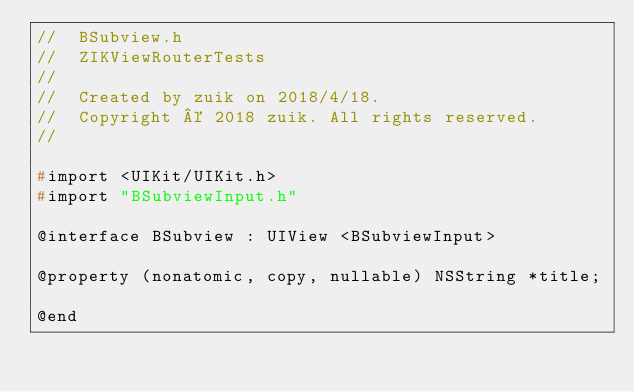Convert code to text. <code><loc_0><loc_0><loc_500><loc_500><_C_>//  BSubview.h
//  ZIKViewRouterTests
//
//  Created by zuik on 2018/4/18.
//  Copyright © 2018 zuik. All rights reserved.
//

#import <UIKit/UIKit.h>
#import "BSubviewInput.h"

@interface BSubview : UIView <BSubviewInput>

@property (nonatomic, copy, nullable) NSString *title;

@end
</code> 